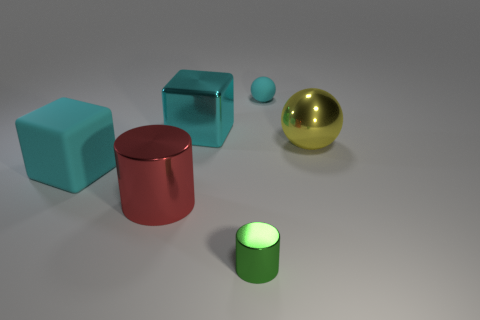The object that is made of the same material as the small ball is what color?
Your answer should be compact. Cyan. Does the green object have the same material as the sphere behind the big yellow metal sphere?
Your answer should be very brief. No. What color is the thing that is both right of the large metallic cube and left of the tiny cyan sphere?
Your answer should be compact. Green. How many cubes are either large cyan things or cyan objects?
Ensure brevity in your answer.  2. There is a big matte object; is its shape the same as the shiny thing in front of the red thing?
Your response must be concise. No. There is a thing that is both to the right of the small green cylinder and in front of the small matte thing; what size is it?
Ensure brevity in your answer.  Large. The big red object has what shape?
Your response must be concise. Cylinder. There is a cyan rubber thing that is on the left side of the tiny green metal thing; are there any large cyan shiny things that are on the left side of it?
Your answer should be very brief. No. How many rubber blocks are to the left of the large red thing in front of the big cyan rubber object?
Offer a terse response. 1. There is a red object that is the same size as the metallic ball; what is its material?
Keep it short and to the point. Metal. 